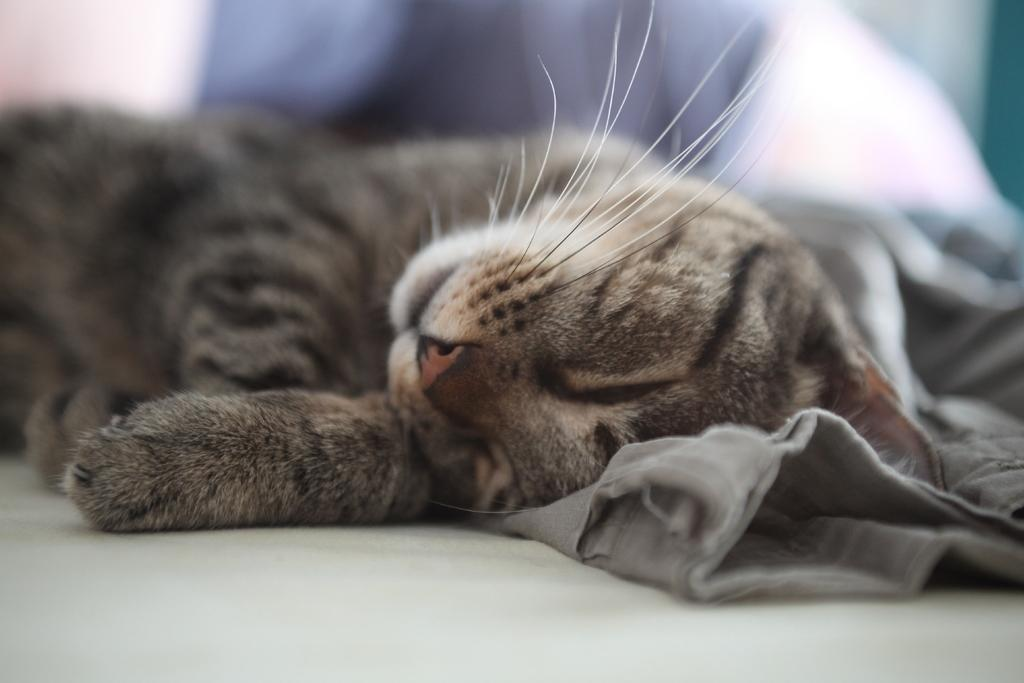What is the primary surface visible in the image? There is a floor in the image. What type of animal can be seen in the image? A cat is sleeping on the cloth in the image. What is the color of the cloth behind the cat? The cloth behind the cat is white, but it is not clearly visible. What type of grain is being harvested by the committee in the image? There is no committee or grain present in the image; it features a cat sleeping on a cloth. How many bushes are visible in the image? There are no bushes visible in the image; it features a cat sleeping on a cloth. 